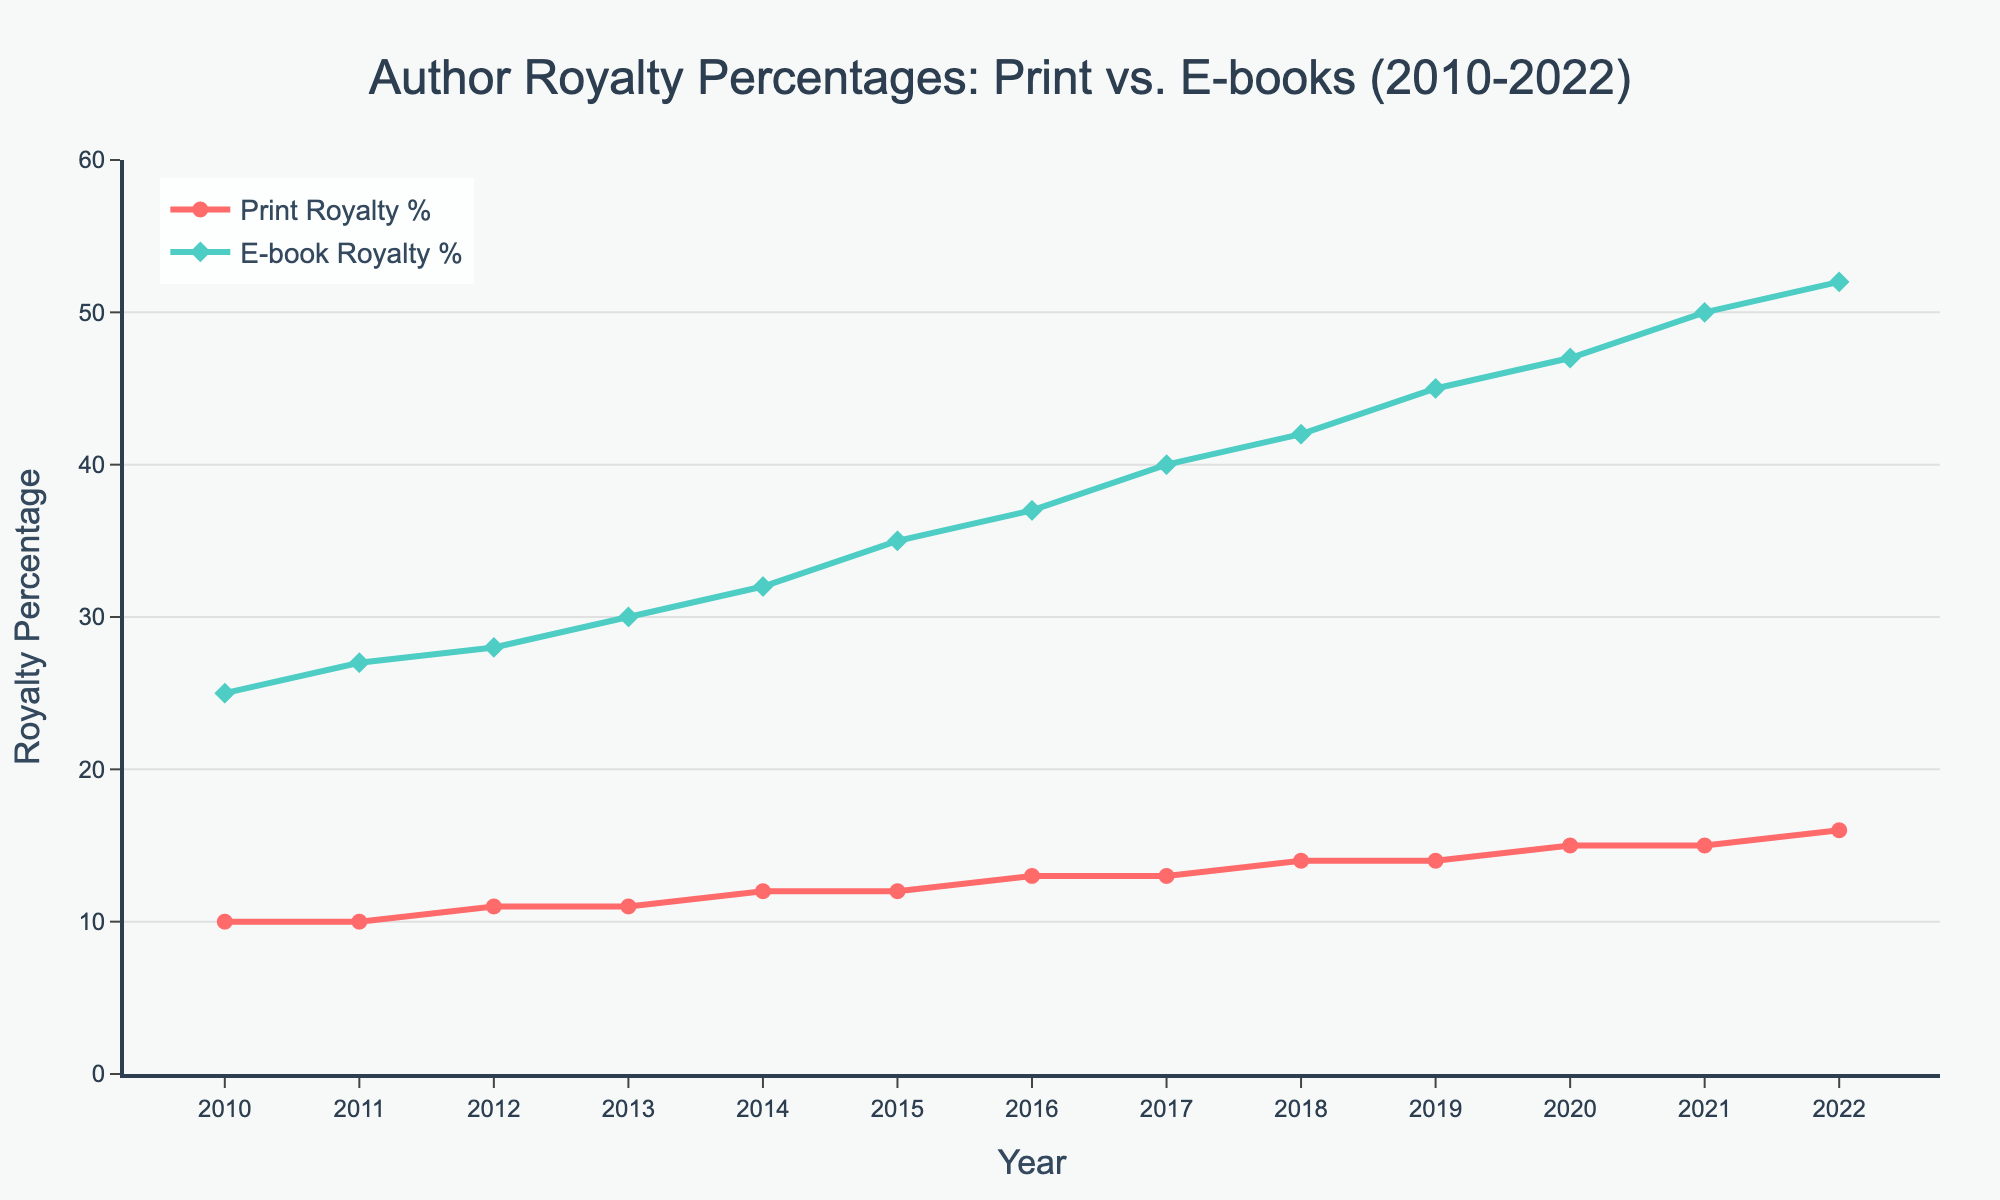What's the trend in Print Royalty % between 2010 and 2022? The trend in Print Royalty % from 2010 to 2022 shows a gradual increase. It started at 10% in 2010 and rose steadily to 16% by 2022.
Answer: Gradual Increase Which had a higher royalty percentage in 2015, Print or E-book? In 2015, Print Royalty % was 12%, while E-book Royalty % was 35%. Therefore, E-book Royalty % was higher.
Answer: E-book What is the difference in Print Royalty % between 2012 and 2016? In 2012, the Print Royalty % was 11%, and in 2016 it was 13%. The difference is 13% - 11% = 2%.
Answer: 2% Which year saw the largest increase in E-book Royalty % from the previous year? From 2010 to 2022, the largest increase in E-book Royalty % was between 2011 and 2012, where it increased from 27% to 28%, a 1% increase.
Answer: 2011-2012 In the year 2020, how much higher was the E-book Royalty % compared to the Print Royalty %? In 2020, the E-book Royalty % was 47%, and the Print Royalty % was 15%. The difference is 47% - 15% = 32%.
Answer: 32% What is the average E-book Royalty % from 2010 to 2015? The values for E-book Royalty % from 2010 to 2015 are 25%, 27%, 28%, 30%, 32%, and 35%. The sum is 177%, and the average is 177% / 6 = 29.5%.
Answer: 29.5% Is the increase in Print Royalty % more consistent or is the increase in E-book Royalty % more consistent over the years? The E-book Royalty % shows a more consistent increase with yearly increments, while the Print Royalty % shows a more gradual and slightly less consistent increase.
Answer: E-book By how much did the Print Royalty % increase from 2010 to 2022? In 2010, the Print Royalty % was 10%, and in 2022, it was 16%. The increase is 16% - 10% = 6%.
Answer: 6% Compare the slopes of the lines representing Print and E-book royalties. Which one is steeper? The slope representing the E-book Royalty % is steeper since it shows a more rapid increase from 25% to 52% over the years compared to the more gradual increase in Print Royalty %.
Answer: E-book 